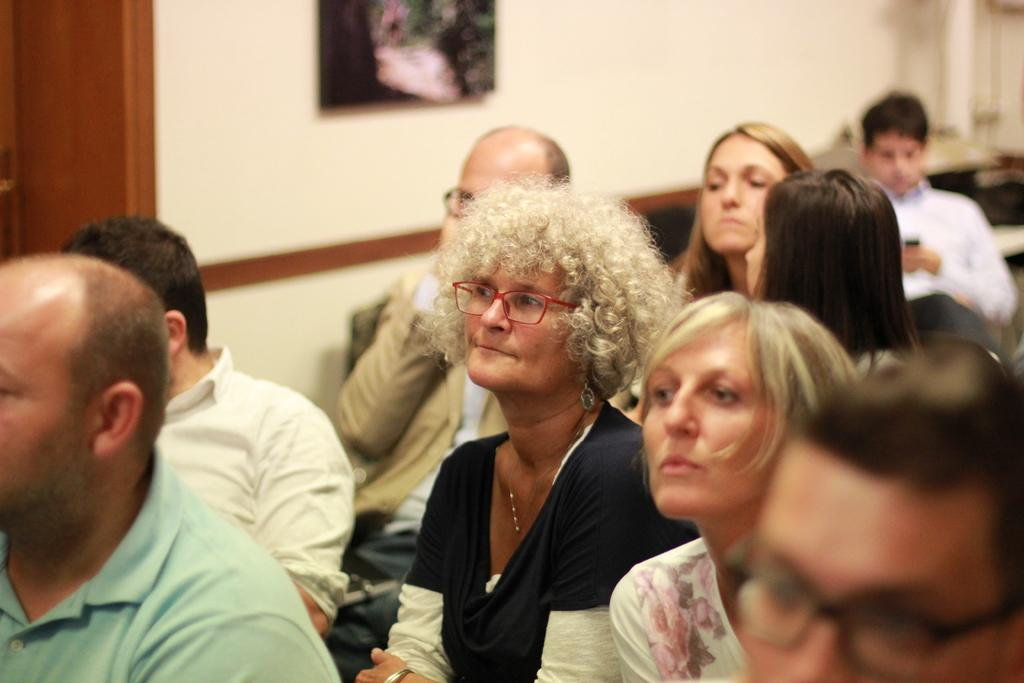How many people are in the image? There are persons in the image, but the exact number is not specified. What can be seen in the background of the image? There is a wall in the background of the image. What is on the wall in the background of the image? There is a frame on the wall in the background of the image. What type of notebook is being used by the organization in the image? There is no notebook or organization present in the image. 